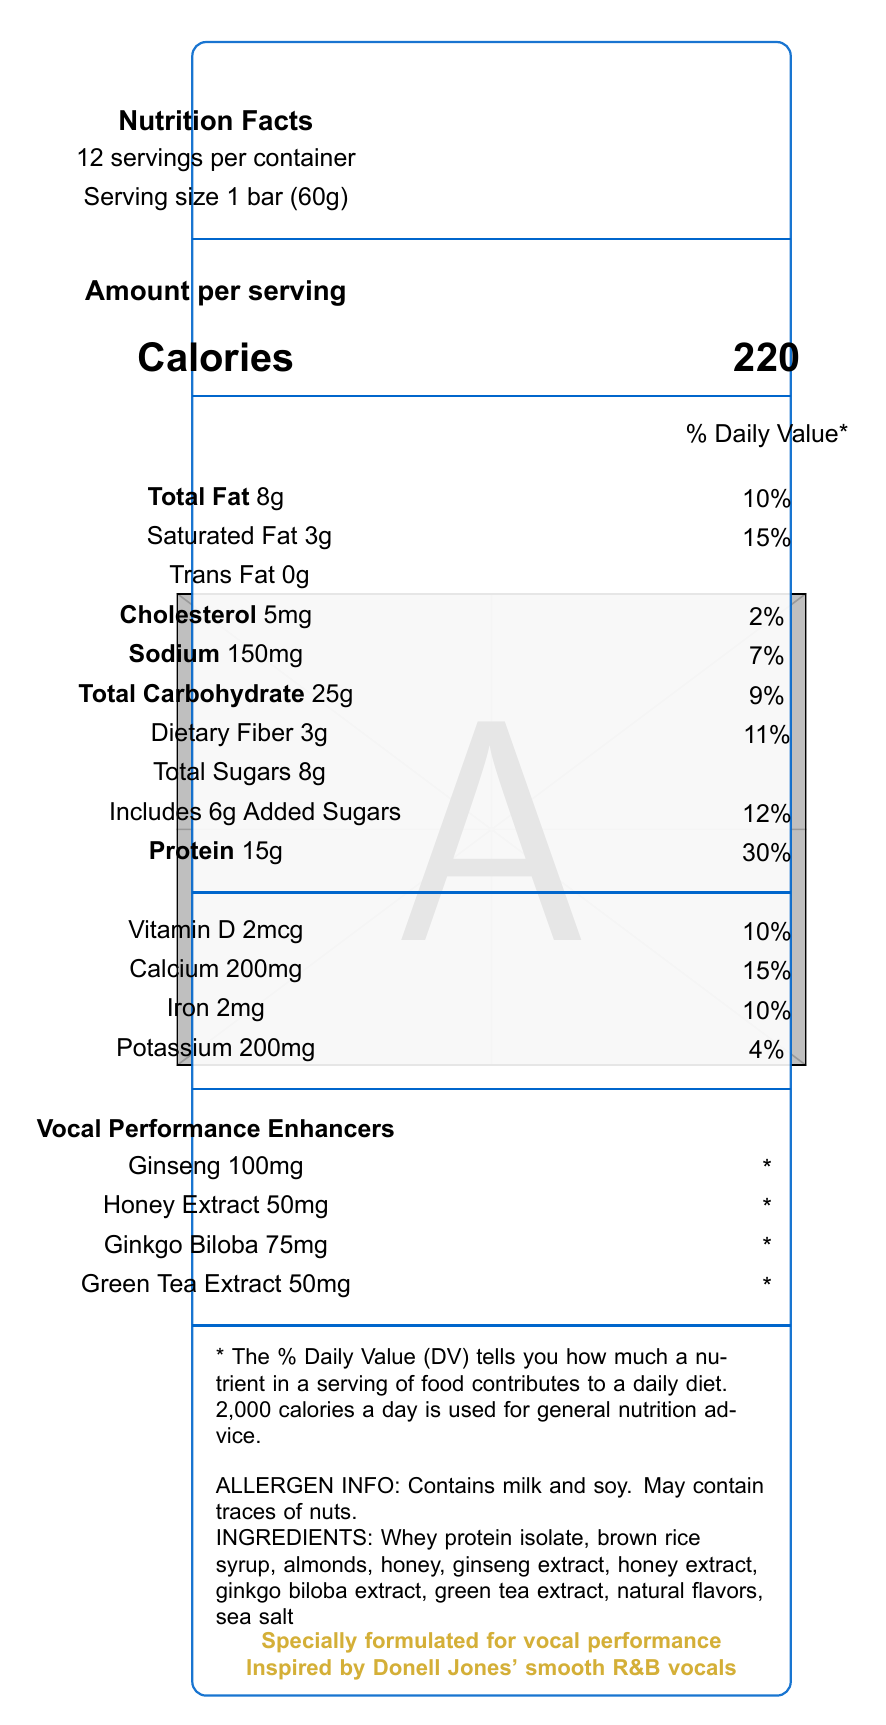what is the serving size? The serving size is listed under "Serving size" in the "Nutrition Facts" section of the document.
Answer: 1 bar (60g) how many calories are in one serving? The calories per serving are shown next to the word "Calories" in the "Amount per serving" section.
Answer: 220 list the vocal performance enhancers present in the product. These ingredients are listed under "Vocal Performance Enhancers".
Answer: Ginseng, Honey Extract, Ginkgo Biloba, Green Tea Extract how much protein does the bar contain per serving? The document states "Protein 15g" under the "Amount per serving" section.
Answer: 15g what percentage of the daily value for vitamin D does one bar provide? The daily value percentage for vitamin D is listed under the "Vitamins" section in the document.
Answer: 10% which of the following allergens are contained in the bar? A. Milk B. Soy C. Nuts D. Wheat The allergen information indicates the bar contains milk and soy and may contain traces of nuts but does not mention wheat.
Answer: A. Milk B. Soy how much sodium is in one bar? A. 100mg B. 150mg C. 200mg D. 210mg The sodium content per serving is listed as "Sodium 150mg."
Answer: B. 150mg is the bar a good source of dietary fiber? The bar provides 3g of dietary fiber, which is 11% of the daily value, indicating it's a good source.
Answer: Yes summarize the main idea of this document. The document mainly focuses on the nutritional content, enhancing properties, and target audience of the protein bar, emphasizing its special formulation for vocal performance.
Answer: The document provides the nutrition facts for the "U Know What's Up" Protein Bar, including its ingredients, allergen information, and special vocal performance-enhancing properties. It highlights the bar's inspiration from Donell Jones' R&B vocals and its claimed benefits for singers. what is the total amount of sugars per serving? The document states "Total Sugars 8g" in the carbohydrate section.
Answer: 8g how does the bar claim to benefit singers? The document lists "Supports vocal endurance and clarity" as a marketing claim.
Answer: Supports vocal endurance and clarity what is the percentage daily value of saturated fat provided by the bar? The amount of saturated fat is listed as "3g" with a daily value of 15%.
Answer: 15% can I find the production date of the bar in the document? The document does not provide any information regarding the production date of the bar.
Answer: Cannot be determined how many servings are in one container? The document states that there are 12 servings per container near the top of the "Nutrition Facts" section.
Answer: 12 which ingredient contributes to the vocal performance-enhancing properties of the bar? These ingredients are specifically mentioned under the "Vocal Performance Enhancers" section.
Answer: Ginseng, Honey Extract, Ginkgo Biloba, Green Tea Extract what are the total carbohydrates in one serving of the bar? A. 20g B. 25g C. 30g D. 35g The total carbohydrates per serving are listed as "Total Carbohydrate 25g" in the "Nutrition Facts" section.
Answer: B. 25g does the bar contain trans fat? The document explicitly states "Trans Fat 0g" indicating that the bar contains no trans fat.
Answer: No what inspired the formulation of the "U Know What's Up" protein bar? The marketing claims mention that the bar is inspired by Donell Jones' smooth R&B vocals.
Answer: Donell Jones' smooth R&B vocals what is the main protein source in the bar's ingredients? According to the ingredient list, the main protein source is whey protein isolate.
Answer: Whey protein isolate how much honey extract is added to the bar per serving? The amount of honey extract per serving is listed under "Vocal Performance Enhancers" as 50mg.
Answer: 50mg 